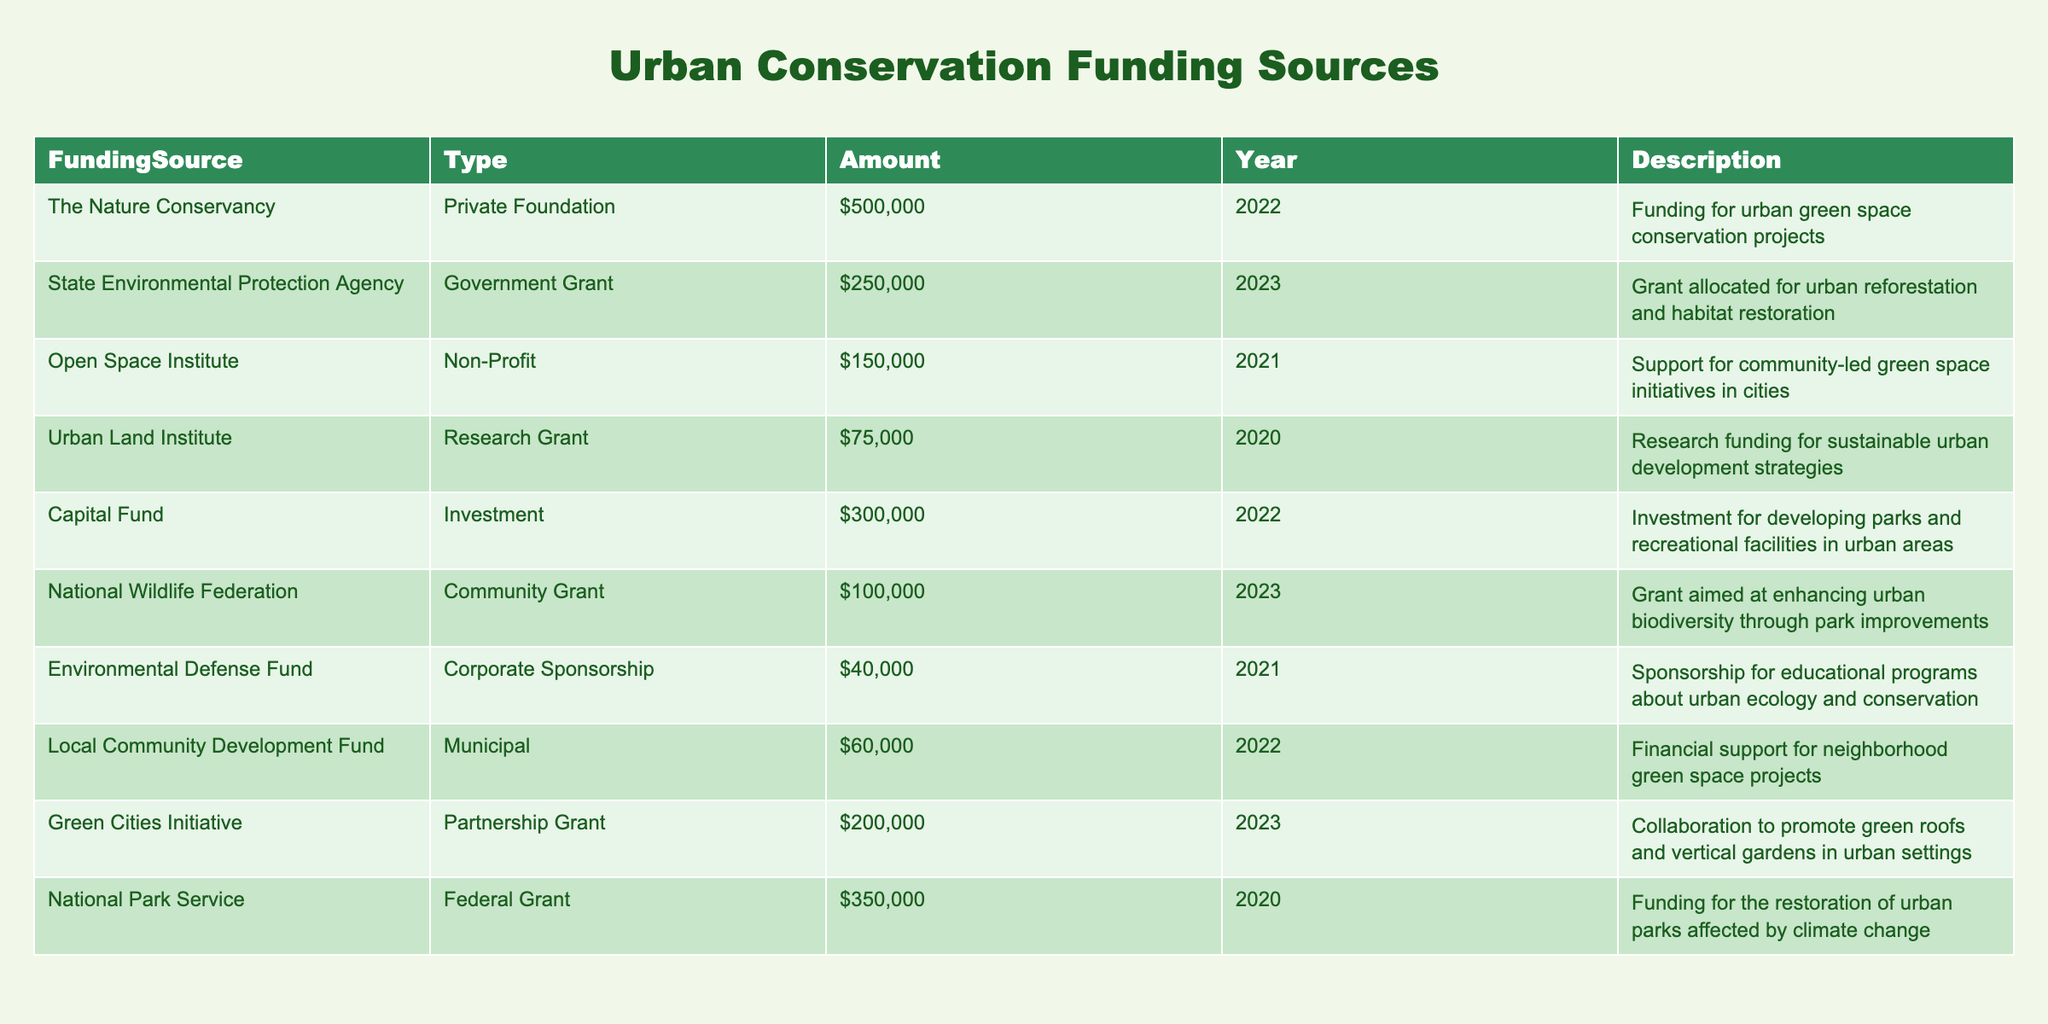What is the total amount of funding from Government Grants? There is one Government Grant listed in the table from the State Environmental Protection Agency for $250,000. Therefore, the total amount from Government Grants is simply $250,000.
Answer: $250,000 Which organization provided funding in 2022 for urban green space conservation projects? The table shows that The Nature Conservancy provided funding of $500,000 in 2022 for urban green space conservation projects.
Answer: The Nature Conservancy Is there any funding source that is classified as a Corporate Sponsorship? The table has a row marked under Corporate Sponsorship, which is from the Environmental Defense Fund for $40,000 in 2021. This confirms that there is indeed one Corporate Sponsorship listed.
Answer: Yes What was the average amount of funding across all Non-Profit sources? The only Non-Profit source listed is the Open Space Institute, which provided $150,000 in 2021. Since there is just one Non-Profit source, the average amount is $150,000 itself as there are no other amounts to average.
Answer: $150,000 Which year had the highest funding amount listed in the table, and what was the amount? Scanning through each row, 2022 shows funding amounts of $500,000 (The Nature Conservancy) and $300,000 (Capital Fund), totaling $800,000, which is higher than any other year. The highest single funding amount from any source is $500,000 from The Nature Conservancy in that year. Thus, the highest funding year is 2022 with $800,000 in total.
Answer: 2022, $800,000 How many different types of funding sources are there in the table? The table lists various funding types: Private Foundation, Government Grant, Non-Profit, Research Grant, Investment, Community Grant, Corporate Sponsorship, Municipal, and Partnership Grant. Counting these gives a total of 9 different types of funding sources.
Answer: 9 